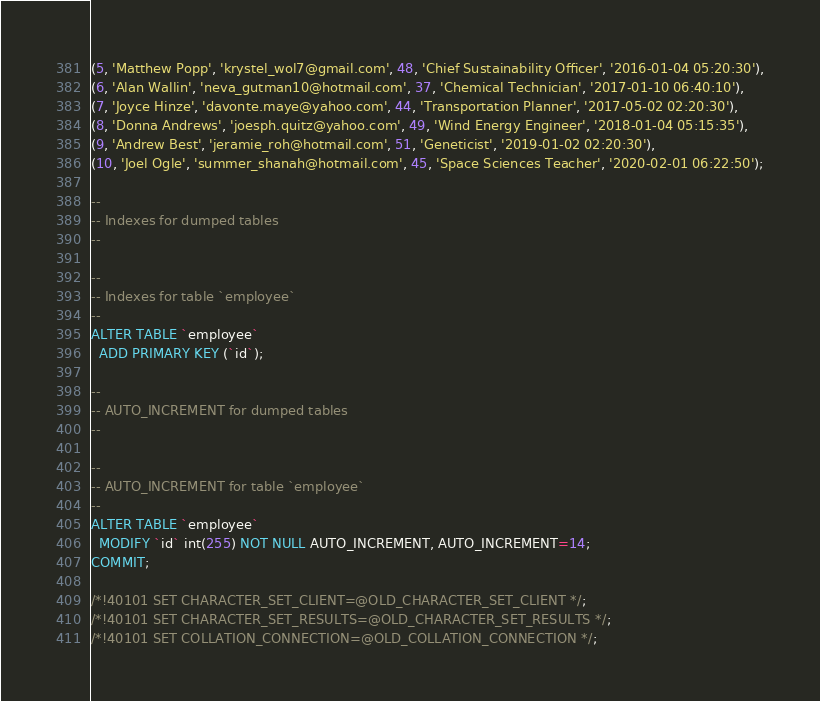<code> <loc_0><loc_0><loc_500><loc_500><_SQL_>(5, 'Matthew Popp', 'krystel_wol7@gmail.com', 48, 'Chief Sustainability Officer', '2016-01-04 05:20:30'),
(6, 'Alan Wallin', 'neva_gutman10@hotmail.com', 37, 'Chemical Technician', '2017-01-10 06:40:10'),
(7, 'Joyce Hinze', 'davonte.maye@yahoo.com', 44, 'Transportation Planner', '2017-05-02 02:20:30'),
(8, 'Donna Andrews', 'joesph.quitz@yahoo.com', 49, 'Wind Energy Engineer', '2018-01-04 05:15:35'),
(9, 'Andrew Best', 'jeramie_roh@hotmail.com', 51, 'Geneticist', '2019-01-02 02:20:30'),
(10, 'Joel Ogle', 'summer_shanah@hotmail.com', 45, 'Space Sciences Teacher', '2020-02-01 06:22:50');

--
-- Indexes for dumped tables
--

--
-- Indexes for table `employee`
--
ALTER TABLE `employee`
  ADD PRIMARY KEY (`id`);

--
-- AUTO_INCREMENT for dumped tables
--

--
-- AUTO_INCREMENT for table `employee`
--
ALTER TABLE `employee`
  MODIFY `id` int(255) NOT NULL AUTO_INCREMENT, AUTO_INCREMENT=14;
COMMIT;

/*!40101 SET CHARACTER_SET_CLIENT=@OLD_CHARACTER_SET_CLIENT */;
/*!40101 SET CHARACTER_SET_RESULTS=@OLD_CHARACTER_SET_RESULTS */;
/*!40101 SET COLLATION_CONNECTION=@OLD_COLLATION_CONNECTION */;
</code> 